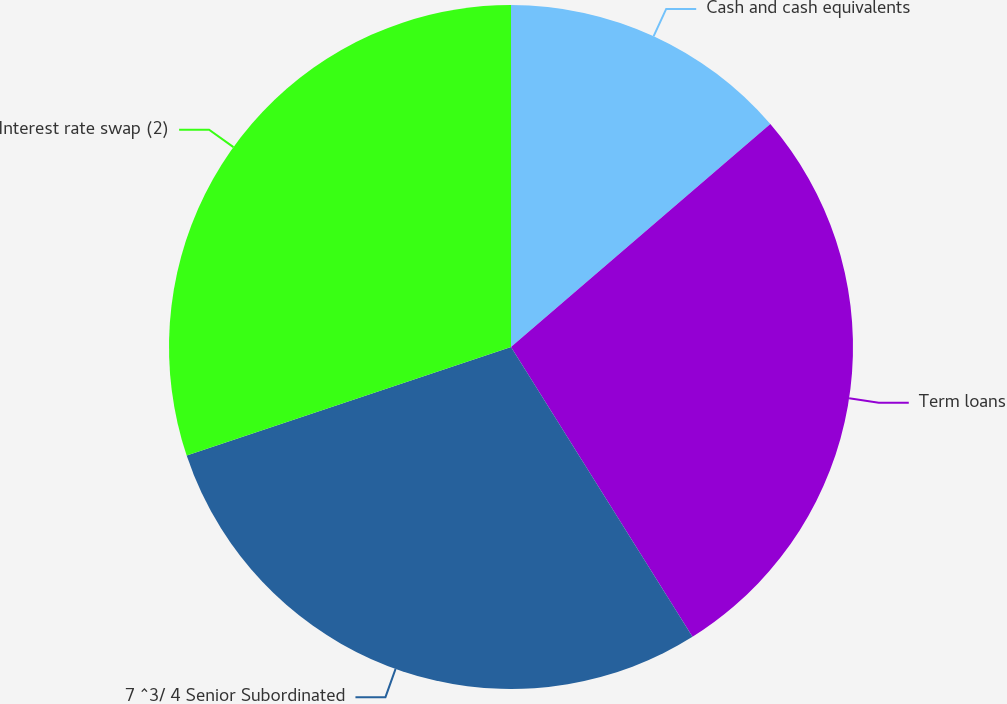Convert chart. <chart><loc_0><loc_0><loc_500><loc_500><pie_chart><fcel>Cash and cash equivalents<fcel>Term loans<fcel>7 ^3/ 4 Senior Subordinated<fcel>Interest rate swap (2)<nl><fcel>13.7%<fcel>27.4%<fcel>28.77%<fcel>30.14%<nl></chart> 